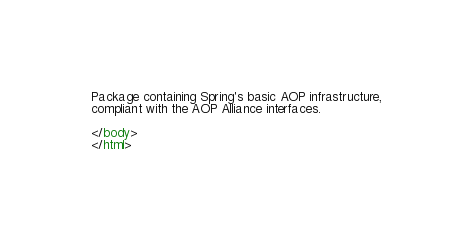<code> <loc_0><loc_0><loc_500><loc_500><_HTML_>
Package containing Spring's basic AOP infrastructure,
compliant with the AOP Alliance interfaces.

</body>
</html>
</code> 